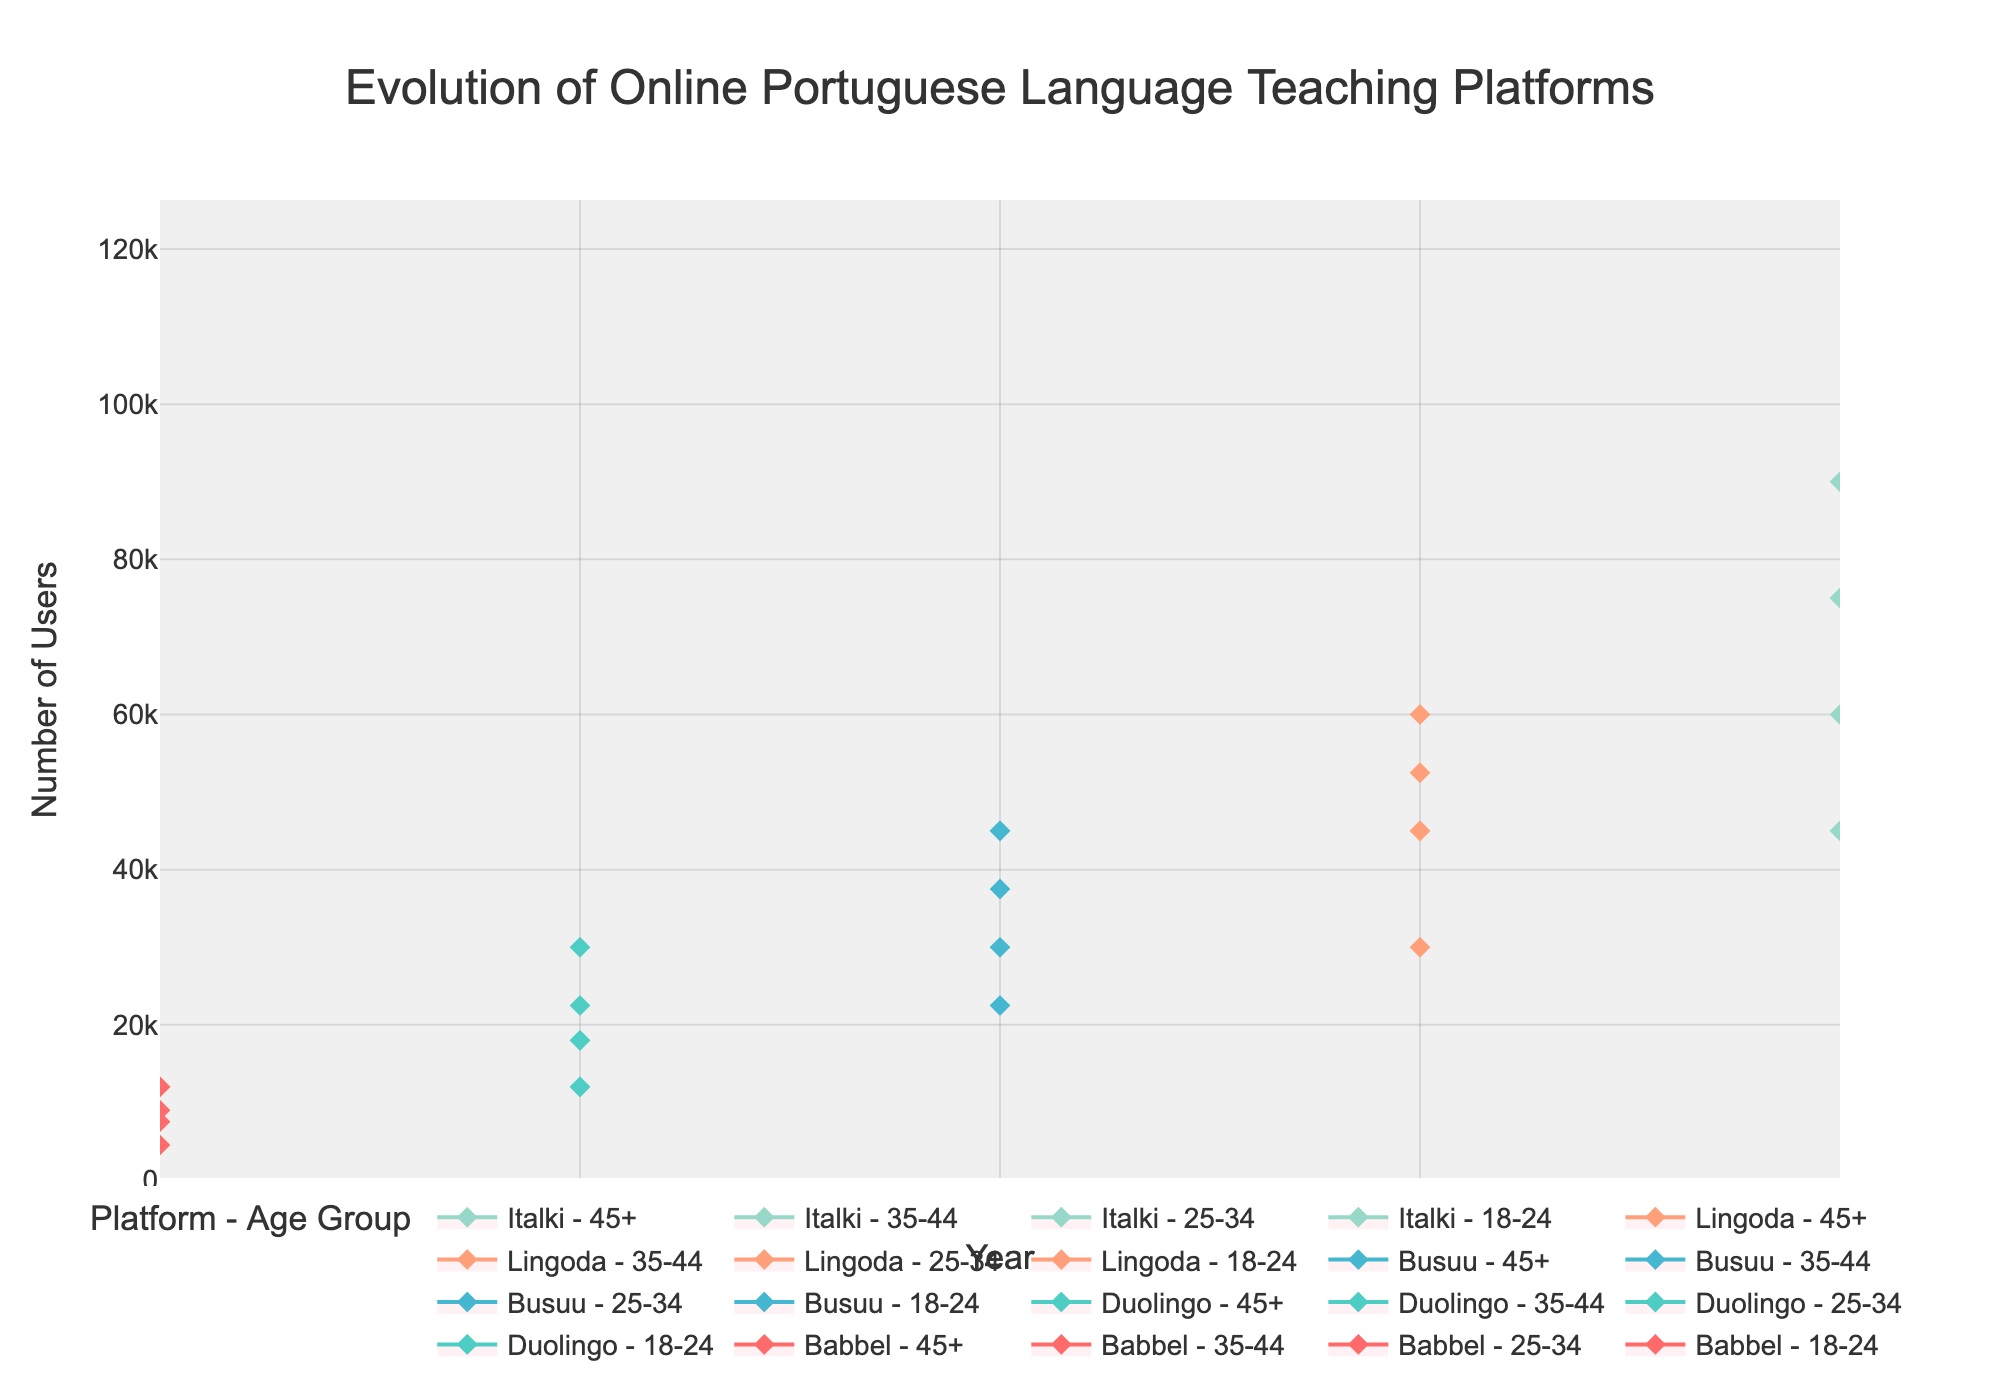What is the highest median number of users for Duolingo in 2019? Refer to the 2019 data for Duolingo. The highest median users are in the 25-34 age group with 30,000 users.
Answer: 30,000 Which platform had the highest median number of users in the 45+ age group in 2021? Refer to the 2021 data. The platform with the highest users in the 45+ age group is Lingoda, with a median of 30,000 users.
Answer: Lingoda How did the median user base for Babbel in the 18-24 age group change from 2018 to 2022? Babbel in 2018 had a median of 7,500 users for 18-24. Compare it with the last year available, 2022. Since no data for Babbel in 2022, compare with the other platform data showing growth patterns.
Answer: No direct comparison What is the trend of the median user base for the 25-34 age group across all platforms from 2018 to 2022? Track all median user numbers for 25-34 from 2018 to 2022 across different platforms. It shows an increasing trend: 12,000 for Babbel in 2018, 30,000 for Duolingo in 2019, 45,000 for Busuu in 2020, 60,000 for Lingoda in 2021, and 90,000 for Italki in 2022.
Answer: Increasing trend In which year did Busuu have a peak in the number of users in the 35-44 age group? Check the data for Busuu across years and age groups. Busuu has data only for 2020, where the peak number (median) of users for the 35-44 age group is 30,000.
Answer: 2020 Which age group showed the most prominent growth across all platforms from 2018 to 2022? Notice the pattern of median users across all platforms for different age groups. The most significant increase is seen in the 18-24 age group: 7,500 (2018), 22,500 (2019), 37,500 (2020), 52,500 (2021), and 75,000 (2022).
Answer: 18-24 Compare the median number of users in the 35-44 age group for Italki in 2022 against Lingoda in 2021. Refer to Italki 2022 and Lingoda 2021 data for the 35-44 age group. Italki has 60,000 users, while Lingoda has 45,000 users.
Answer: Italki: 60,000, Lingoda: 45,000 